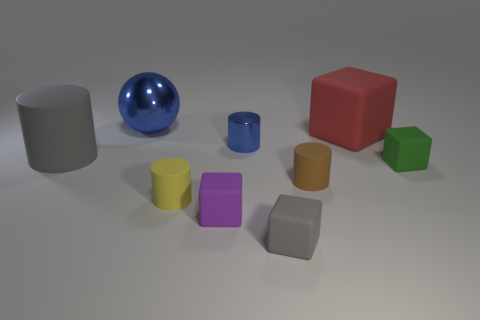Subtract all matte cylinders. How many cylinders are left? 1 Subtract all yellow cylinders. How many cylinders are left? 3 Subtract 3 blocks. How many blocks are left? 1 Subtract all brown cylinders. Subtract all cyan blocks. How many cylinders are left? 3 Subtract all blue objects. Subtract all yellow things. How many objects are left? 6 Add 6 green matte things. How many green matte things are left? 7 Add 6 large matte things. How many large matte things exist? 8 Subtract 0 cyan spheres. How many objects are left? 9 Subtract all cubes. How many objects are left? 5 